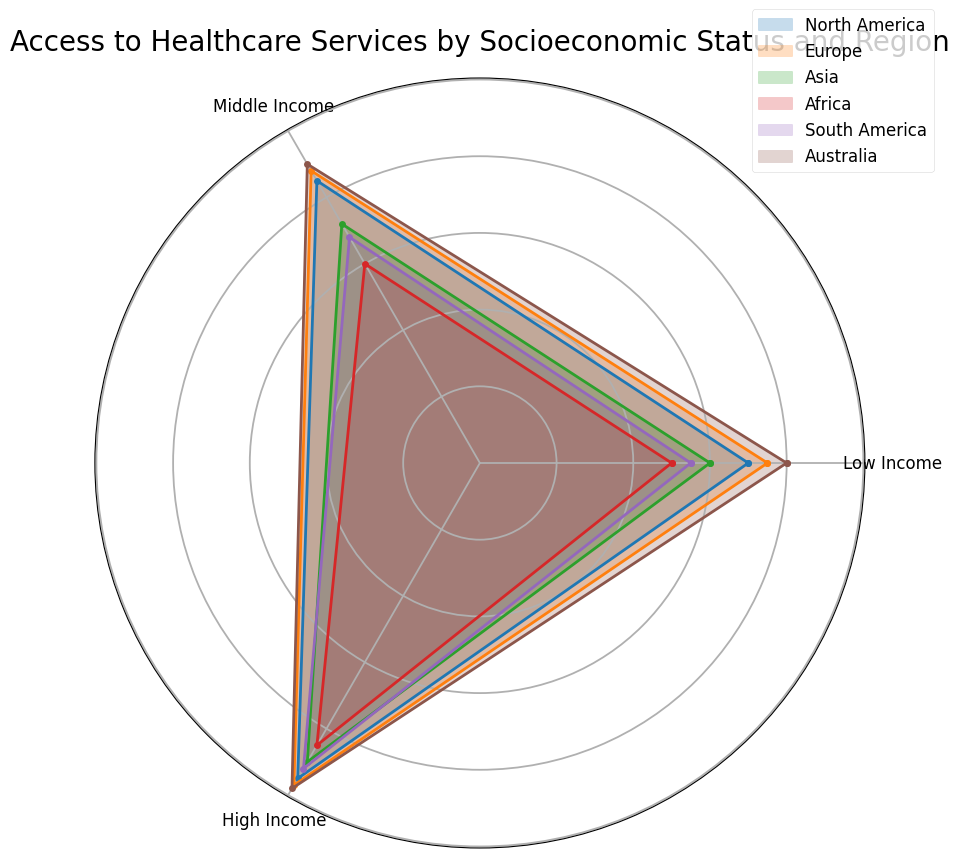Which region has the highest access to healthcare services for high-income individuals? Observe the radar chart for the section labeled 'High Income'. The region with the highest value on this radial axis is Australia.
Answer: Australia Which region shows the greatest disparity in healthcare access between low-income and high-income individuals? To determine the disparity, find the difference between the high-income and low-income values for each region. Australia has the highest disparity, with a difference of 18 (98-80 = 18).
Answer: Australia What is the average access to healthcare services for middle-income individuals across all regions? To find the average, sum the middle-income values for all regions and divide by the number of regions: (85+88+72+60+68+90) / 6 = 77.17
Answer: 77.17 How does access to healthcare for low-income individuals in South America compare to Europe? Compare the values for low-income individuals in both regions. South America has a value of 55, and Europe has 75. Therefore, South America has lower access to healthcare for low-income individuals compared to Europe.
Answer: South America has lower access Which region has the smallest difference in healthcare access between middle-income and high-income individuals? Calculate the difference between middle-income and high-income values for each region: North America (10), Europe (9), Asia (18), Africa (25), South America (24), Australia (8). Australia has the smallest difference of 8.
Answer: Australia What is the visual color representing Europe, and how can you identify it? The visually observed color for Europe can be identified by looking at the radar chart and legend. Europe is assigned a distinct color in both the legend and corresponding section of the radar.
Answer: The specific color for Europe in the legend and radar chart Compare the access to healthcare for middle-income individuals in North America and South America. Which region has higher access? Look at the middle-income values for both regions. North America has a value of 85, and South America has a value of 68. Therefore, North America has higher access for middle-income individuals.
Answer: North America What's the median value of healthcare access for low-income individuals across all regions? Organize the low-income values in ascending order: 50, 55, 60, 70, 75, 80. The median is the average of the middle two values: (60+70)/2 = 65.
Answer: 65 